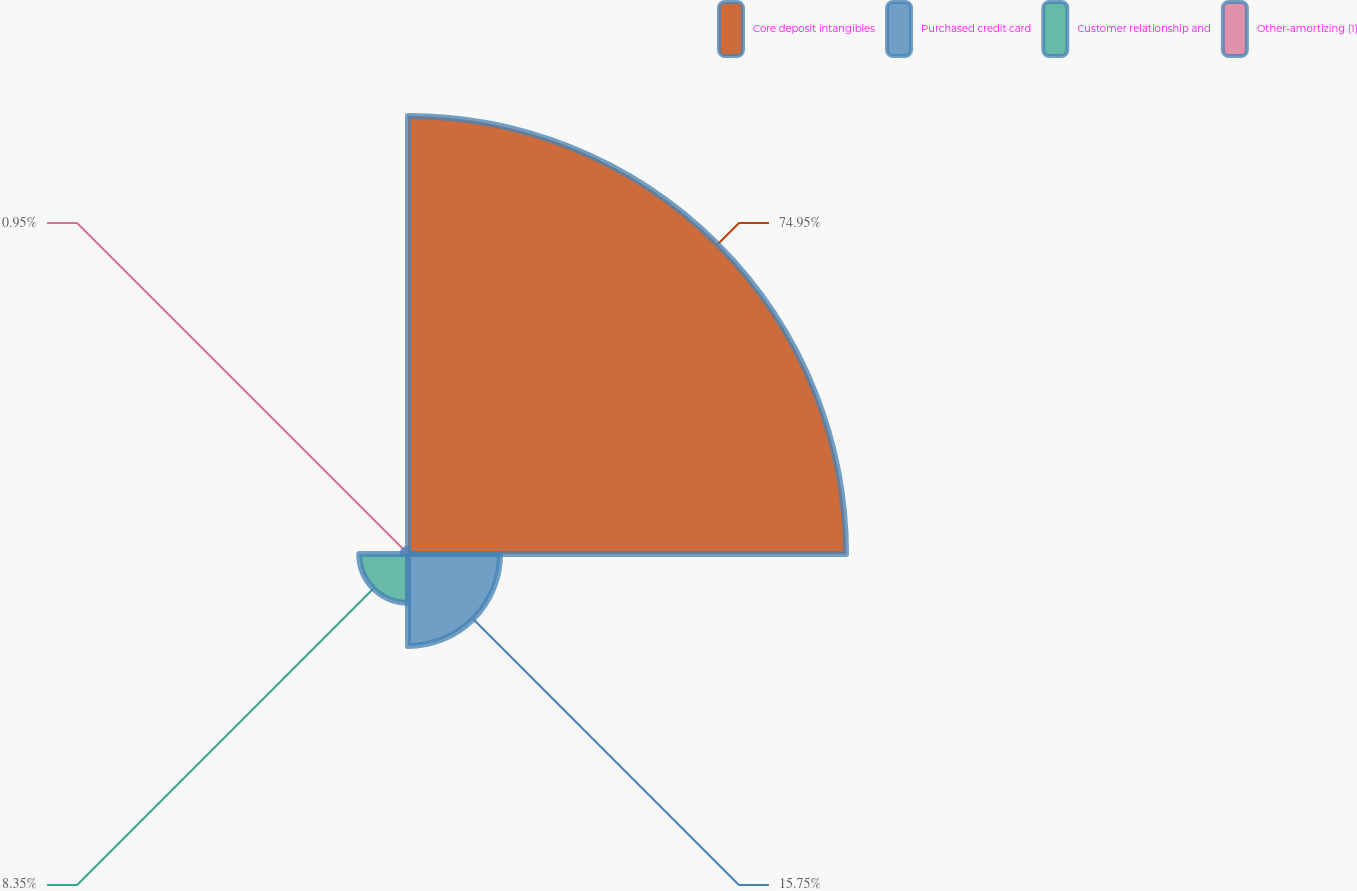<chart> <loc_0><loc_0><loc_500><loc_500><pie_chart><fcel>Core deposit intangibles<fcel>Purchased credit card<fcel>Customer relationship and<fcel>Other-amortizing (1)<nl><fcel>74.96%<fcel>15.75%<fcel>8.35%<fcel>0.95%<nl></chart> 